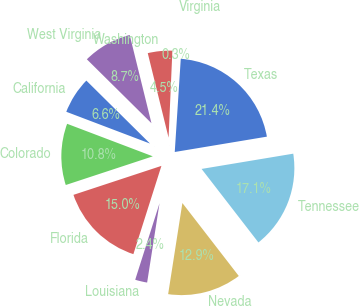<chart> <loc_0><loc_0><loc_500><loc_500><pie_chart><fcel>California<fcel>Colorado<fcel>Florida<fcel>Louisiana<fcel>Nevada<fcel>Tennessee<fcel>Texas<fcel>Virginia<fcel>Washington<fcel>West Virginia<nl><fcel>6.64%<fcel>10.84%<fcel>15.04%<fcel>2.43%<fcel>12.94%<fcel>17.15%<fcel>21.35%<fcel>0.33%<fcel>4.54%<fcel>8.74%<nl></chart> 